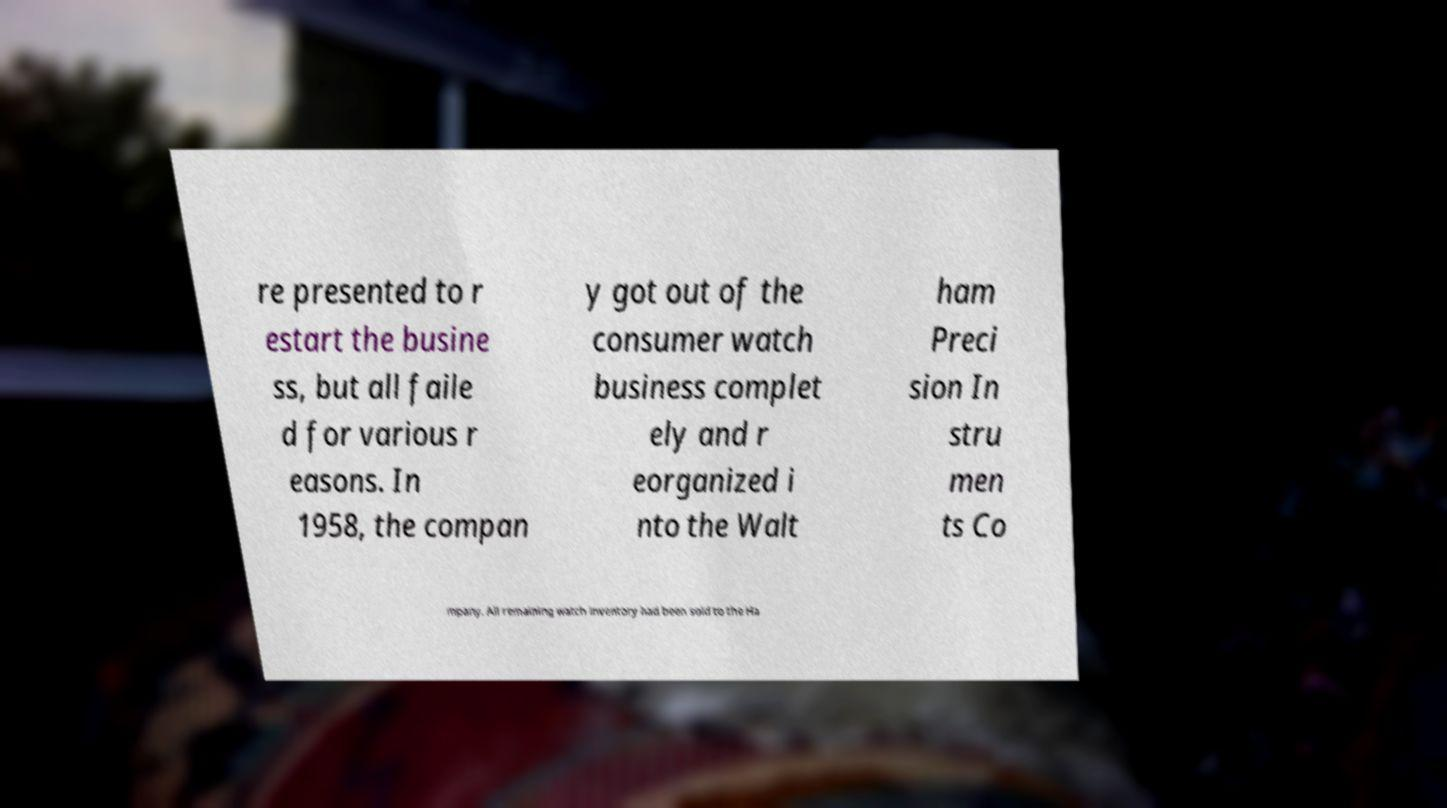There's text embedded in this image that I need extracted. Can you transcribe it verbatim? re presented to r estart the busine ss, but all faile d for various r easons. In 1958, the compan y got out of the consumer watch business complet ely and r eorganized i nto the Walt ham Preci sion In stru men ts Co mpany. All remaining watch inventory had been sold to the Ha 